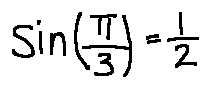<formula> <loc_0><loc_0><loc_500><loc_500>\sin ( \frac { \pi } { 3 } ) = \frac { 1 } { 2 }</formula> 